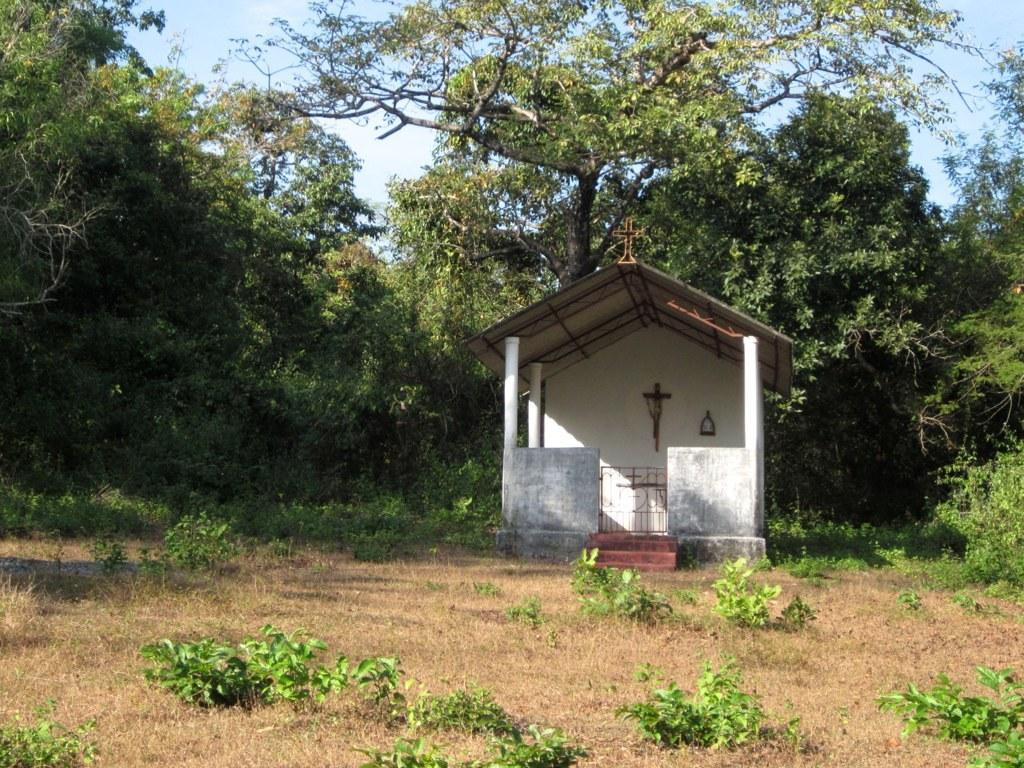What type of plants can be seen at the bottom of the image? There are small plants at the bottom side of the image. What structure is depicted in the image? The image appears to depict a shed of a church. What can be seen in the background of the image? There are trees and the sky visible in the background of the image. What type of silk is used to cover the shed in the image? There is no silk present in the image; the shed appears to be made of wood or other materials. Can you see a rabbit hopping around the small plants in the image? There is no rabbit present in the image; only small plants, a shed, trees, and the sky are visible. 